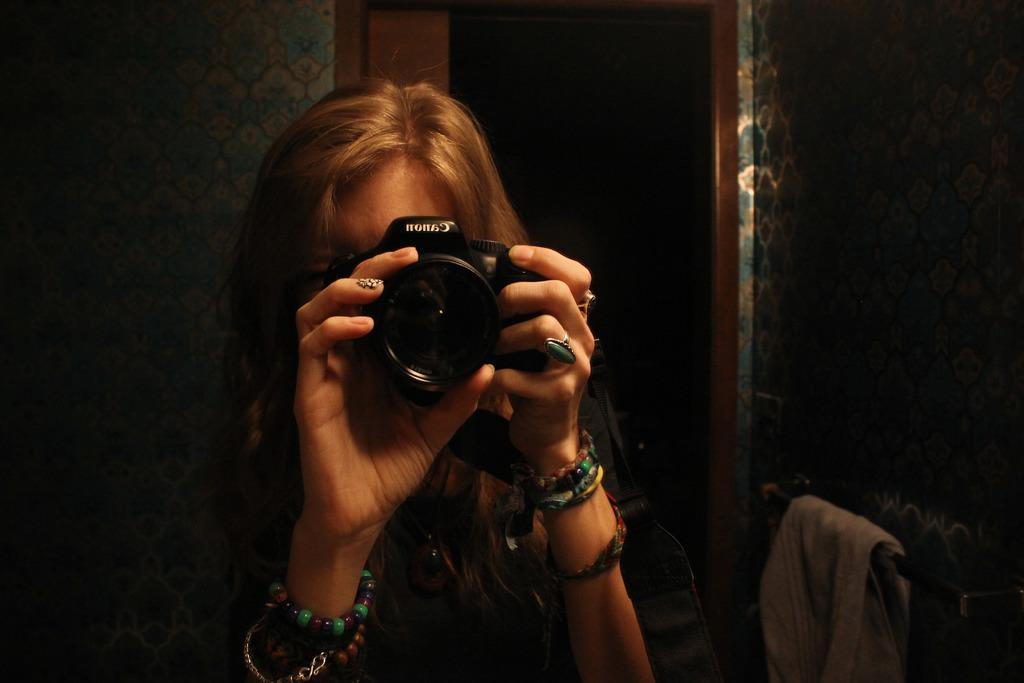Who is the main subject in the picture? There is a girl in the picture. What is the girl holding in the picture? The girl is holding a Canon camera. What is the girl doing with the camera? The girl is posing for the camera. What can be seen in the background of the picture? There is a white wall and a glass window in the background. What type of owl can be seen sitting on the girl's shoulder in the image? There is no owl present in the image; the girl is holding a Canon camera. What is the girl using to paint the white wall in the background? There is no brush or painting activity present in the image; the girl is posing for the camera. 